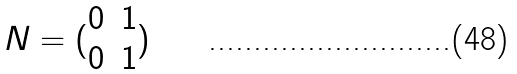Convert formula to latex. <formula><loc_0><loc_0><loc_500><loc_500>N = ( \begin{matrix} 0 & 1 \\ 0 & 1 \end{matrix} )</formula> 